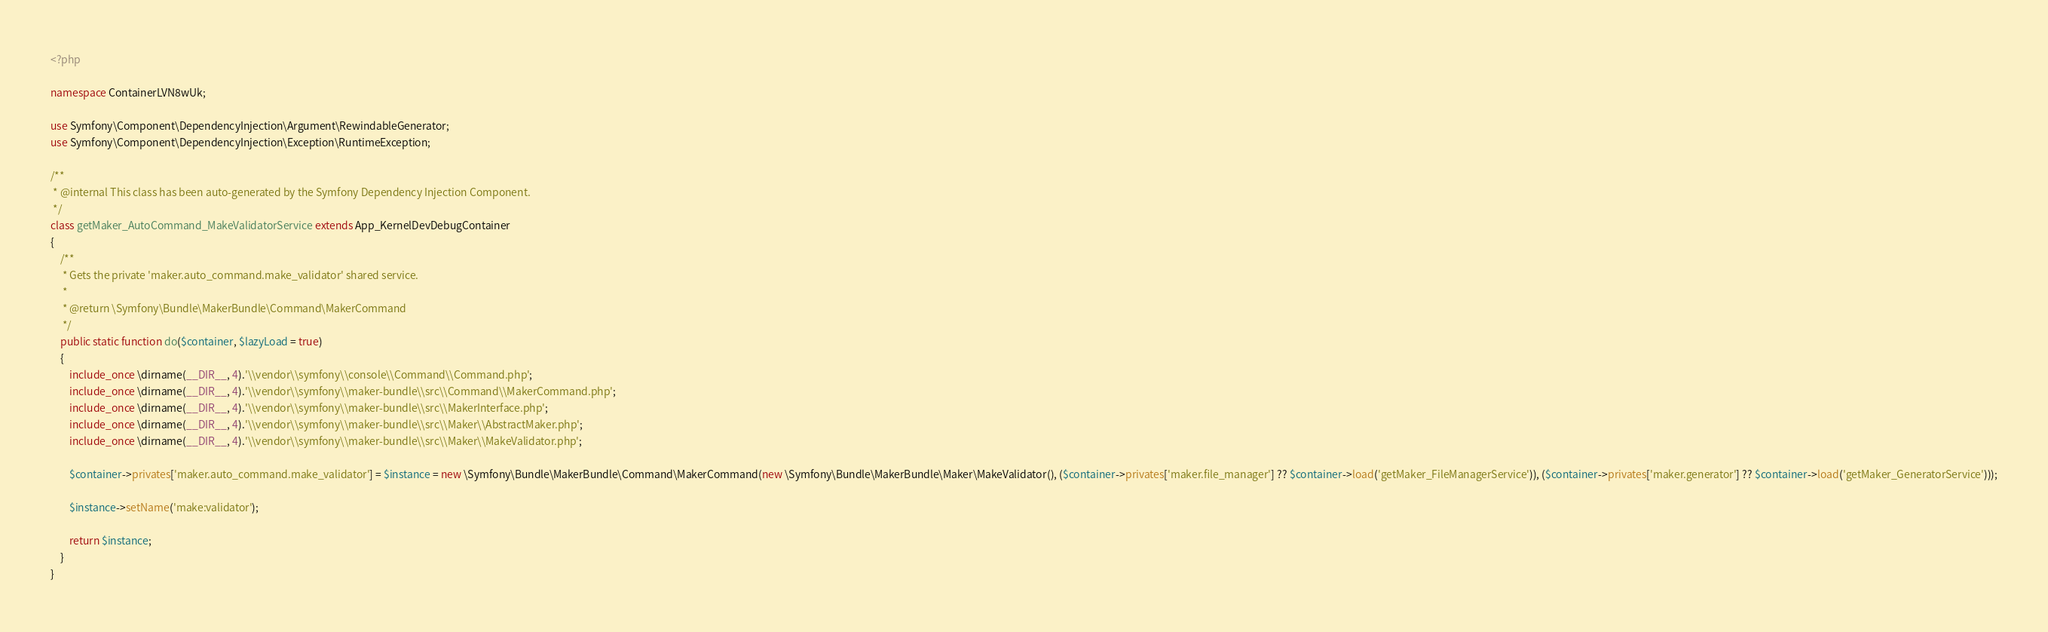Convert code to text. <code><loc_0><loc_0><loc_500><loc_500><_PHP_><?php

namespace ContainerLVN8wUk;

use Symfony\Component\DependencyInjection\Argument\RewindableGenerator;
use Symfony\Component\DependencyInjection\Exception\RuntimeException;

/**
 * @internal This class has been auto-generated by the Symfony Dependency Injection Component.
 */
class getMaker_AutoCommand_MakeValidatorService extends App_KernelDevDebugContainer
{
    /**
     * Gets the private 'maker.auto_command.make_validator' shared service.
     *
     * @return \Symfony\Bundle\MakerBundle\Command\MakerCommand
     */
    public static function do($container, $lazyLoad = true)
    {
        include_once \dirname(__DIR__, 4).'\\vendor\\symfony\\console\\Command\\Command.php';
        include_once \dirname(__DIR__, 4).'\\vendor\\symfony\\maker-bundle\\src\\Command\\MakerCommand.php';
        include_once \dirname(__DIR__, 4).'\\vendor\\symfony\\maker-bundle\\src\\MakerInterface.php';
        include_once \dirname(__DIR__, 4).'\\vendor\\symfony\\maker-bundle\\src\\Maker\\AbstractMaker.php';
        include_once \dirname(__DIR__, 4).'\\vendor\\symfony\\maker-bundle\\src\\Maker\\MakeValidator.php';

        $container->privates['maker.auto_command.make_validator'] = $instance = new \Symfony\Bundle\MakerBundle\Command\MakerCommand(new \Symfony\Bundle\MakerBundle\Maker\MakeValidator(), ($container->privates['maker.file_manager'] ?? $container->load('getMaker_FileManagerService')), ($container->privates['maker.generator'] ?? $container->load('getMaker_GeneratorService')));

        $instance->setName('make:validator');

        return $instance;
    }
}
</code> 